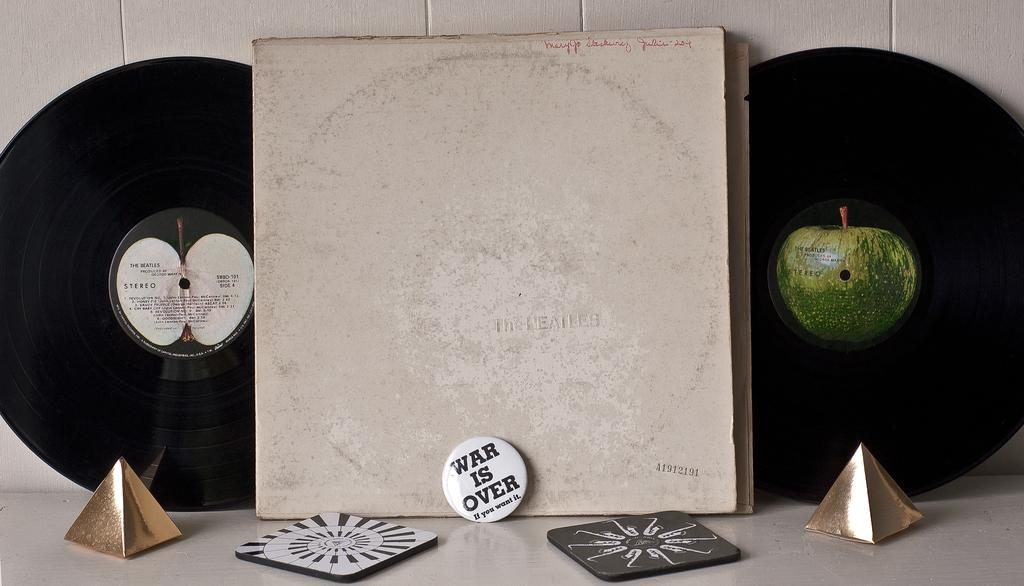What is the main object in the image? There is a board in the image. What is placed on the board? There are discs and fruits in the middle of the discs on the board. What is the color of the surface the objects are placed on? The objects are on a white surface. What can be seen in the background of the image? There is a wall in the background of the image. How many clocks are present on the desk in the image? There is no desk or clocks present in the image. What emotion is being expressed by the fruits in the image? The fruits do not express emotions; they are simply objects in the image. 